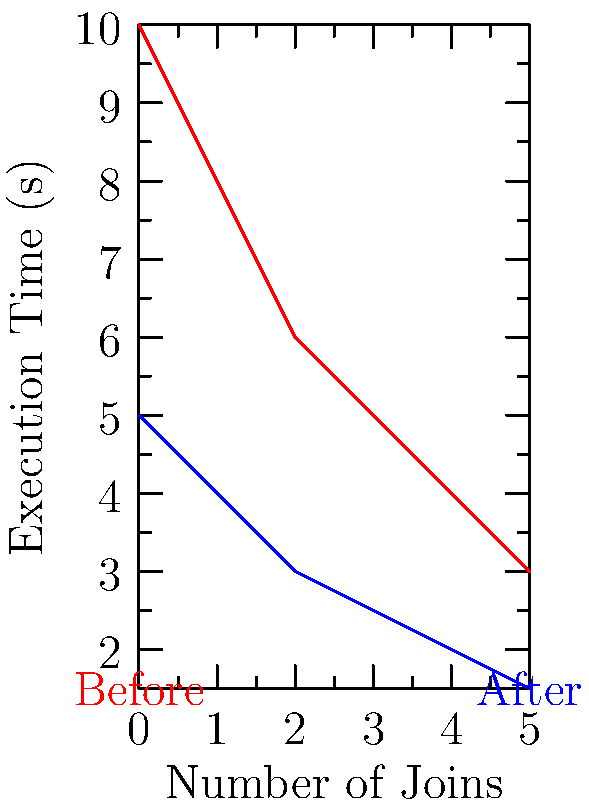The graph shows the execution times of SQL queries before and after optimization, plotted against the number of joins in the query. If the "After Optimization" curve is a uniform scaling of the "Before Optimization" curve, what is the scale factor applied to reduce the execution times? To determine the scale factor, we need to compare corresponding points on the two curves:

1. Choose a point on the x-axis, e.g., x = 3 (3 joins).
2. Find the y-values for this x-value on both curves:
   - Before optimization: y ≈ 5 seconds
   - After optimization: y ≈ 2.5 seconds
3. Calculate the ratio of these y-values:
   $\text{Scale factor} = \frac{\text{After}}{\text{Before}} = \frac{2.5}{5} = 0.5$

4. Verify this scale factor for other points:
   - At x = 0: $\frac{5}{10} = 0.5$
   - At x = 5: $\frac{1.5}{3} = 0.5$

The scale factor is consistent across all points, confirming a uniform scaling.
Answer: 0.5 